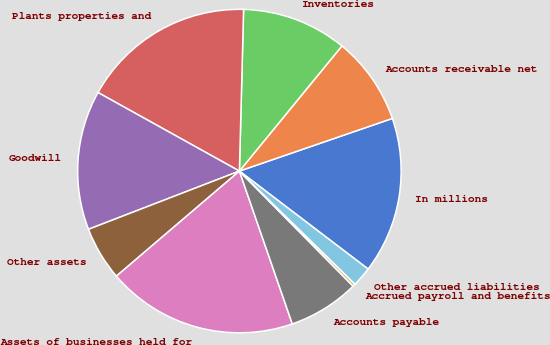<chart> <loc_0><loc_0><loc_500><loc_500><pie_chart><fcel>In millions<fcel>Accounts receivable net<fcel>Inventories<fcel>Plants properties and<fcel>Goodwill<fcel>Other assets<fcel>Assets of businesses held for<fcel>Accounts payable<fcel>Accrued payroll and benefits<fcel>Other accrued liabilities<nl><fcel>15.63%<fcel>8.8%<fcel>10.51%<fcel>17.34%<fcel>13.93%<fcel>5.39%<fcel>19.05%<fcel>7.1%<fcel>0.27%<fcel>1.97%<nl></chart> 